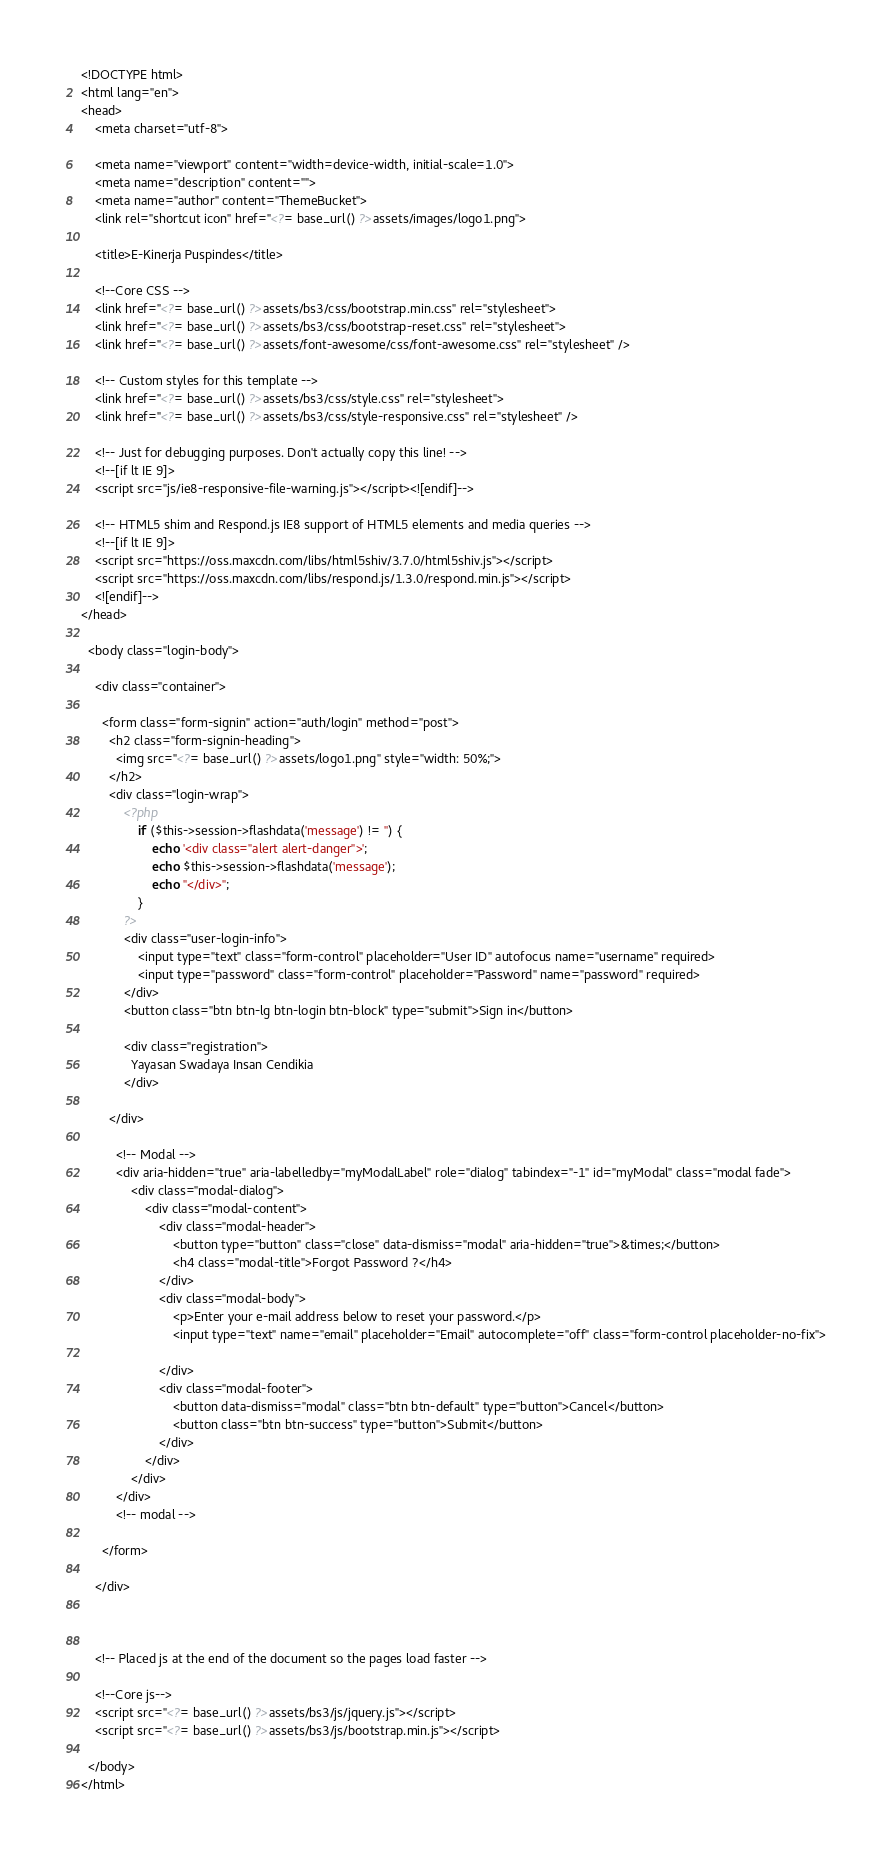<code> <loc_0><loc_0><loc_500><loc_500><_PHP_>
<!DOCTYPE html>
<html lang="en">
<head>
    <meta charset="utf-8">

    <meta name="viewport" content="width=device-width, initial-scale=1.0">
    <meta name="description" content="">
    <meta name="author" content="ThemeBucket">
    <link rel="shortcut icon" href="<?= base_url() ?>assets/images/logo1.png">

    <title>E-Kinerja Puspindes</title>

    <!--Core CSS -->
    <link href="<?= base_url() ?>assets/bs3/css/bootstrap.min.css" rel="stylesheet">
    <link href="<?= base_url() ?>assets/bs3/css/bootstrap-reset.css" rel="stylesheet">
    <link href="<?= base_url() ?>assets/font-awesome/css/font-awesome.css" rel="stylesheet" />

    <!-- Custom styles for this template -->
    <link href="<?= base_url() ?>assets/bs3/css/style.css" rel="stylesheet">
    <link href="<?= base_url() ?>assets/bs3/css/style-responsive.css" rel="stylesheet" />

    <!-- Just for debugging purposes. Don't actually copy this line! -->
    <!--[if lt IE 9]>
    <script src="js/ie8-responsive-file-warning.js"></script><![endif]-->

    <!-- HTML5 shim and Respond.js IE8 support of HTML5 elements and media queries -->
    <!--[if lt IE 9]>
    <script src="https://oss.maxcdn.com/libs/html5shiv/3.7.0/html5shiv.js"></script>
    <script src="https://oss.maxcdn.com/libs/respond.js/1.3.0/respond.min.js"></script>
    <![endif]-->
</head>

  <body class="login-body">

    <div class="container">

      <form class="form-signin" action="auth/login" method="post">
        <h2 class="form-signin-heading">
          <img src="<?= base_url() ?>assets/logo1.png" style="width: 50%;">
        </h2>
        <div class="login-wrap">
        	<?php
				if ($this->session->flashdata('message') != '') {
					echo '<div class="alert alert-danger">';
					echo $this->session->flashdata('message');
					echo "</div>";
				}
        	?>
            <div class="user-login-info">
                <input type="text" class="form-control" placeholder="User ID" autofocus name="username" required>
                <input type="password" class="form-control" placeholder="Password" name="password" required>
            </div>
            <button class="btn btn-lg btn-login btn-block" type="submit">Sign in</button>

            <div class="registration">
              Yayasan Swadaya Insan Cendikia
            </div>

        </div>

          <!-- Modal -->
          <div aria-hidden="true" aria-labelledby="myModalLabel" role="dialog" tabindex="-1" id="myModal" class="modal fade">
              <div class="modal-dialog">
                  <div class="modal-content">
                      <div class="modal-header">
                          <button type="button" class="close" data-dismiss="modal" aria-hidden="true">&times;</button>
                          <h4 class="modal-title">Forgot Password ?</h4>
                      </div>
                      <div class="modal-body">
                          <p>Enter your e-mail address below to reset your password.</p>
                          <input type="text" name="email" placeholder="Email" autocomplete="off" class="form-control placeholder-no-fix">

                      </div>
                      <div class="modal-footer">
                          <button data-dismiss="modal" class="btn btn-default" type="button">Cancel</button>
                          <button class="btn btn-success" type="button">Submit</button>
                      </div>
                  </div>
              </div>
          </div>
          <!-- modal -->

      </form>

    </div>



    <!-- Placed js at the end of the document so the pages load faster -->

    <!--Core js-->
    <script src="<?= base_url() ?>assets/bs3/js/jquery.js"></script>
    <script src="<?= base_url() ?>assets/bs3/js/bootstrap.min.js"></script>

  </body>
</html>
</code> 